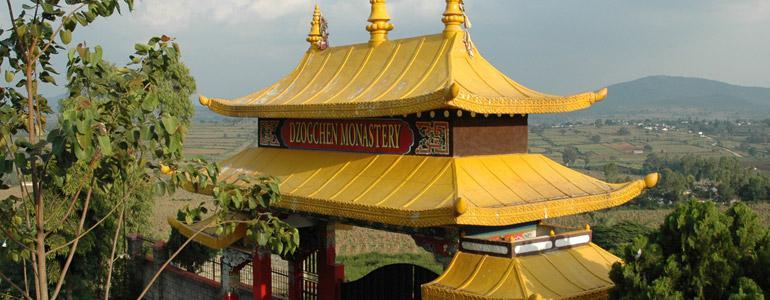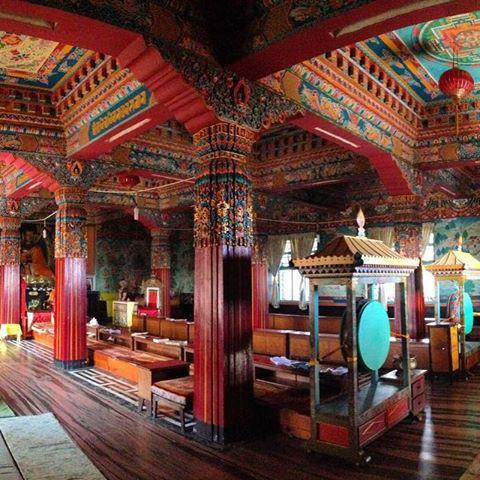The first image is the image on the left, the second image is the image on the right. For the images displayed, is the sentence "Each image shows the outside of a building, no statues or indoors." factually correct? Answer yes or no. No. The first image is the image on the left, the second image is the image on the right. Given the left and right images, does the statement "An image shows a string of colored flags suspended near a building with hills and trees behind it." hold true? Answer yes or no. No. 